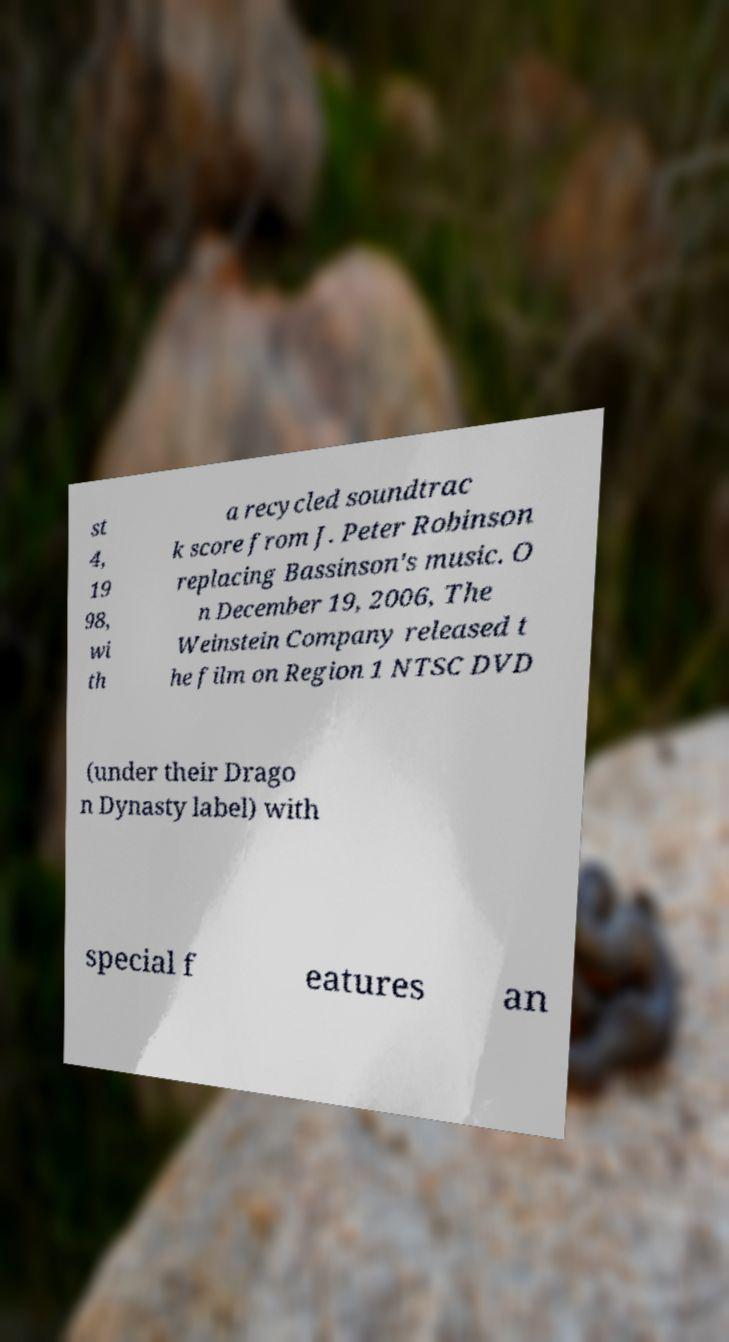I need the written content from this picture converted into text. Can you do that? st 4, 19 98, wi th a recycled soundtrac k score from J. Peter Robinson replacing Bassinson's music. O n December 19, 2006, The Weinstein Company released t he film on Region 1 NTSC DVD (under their Drago n Dynasty label) with special f eatures an 